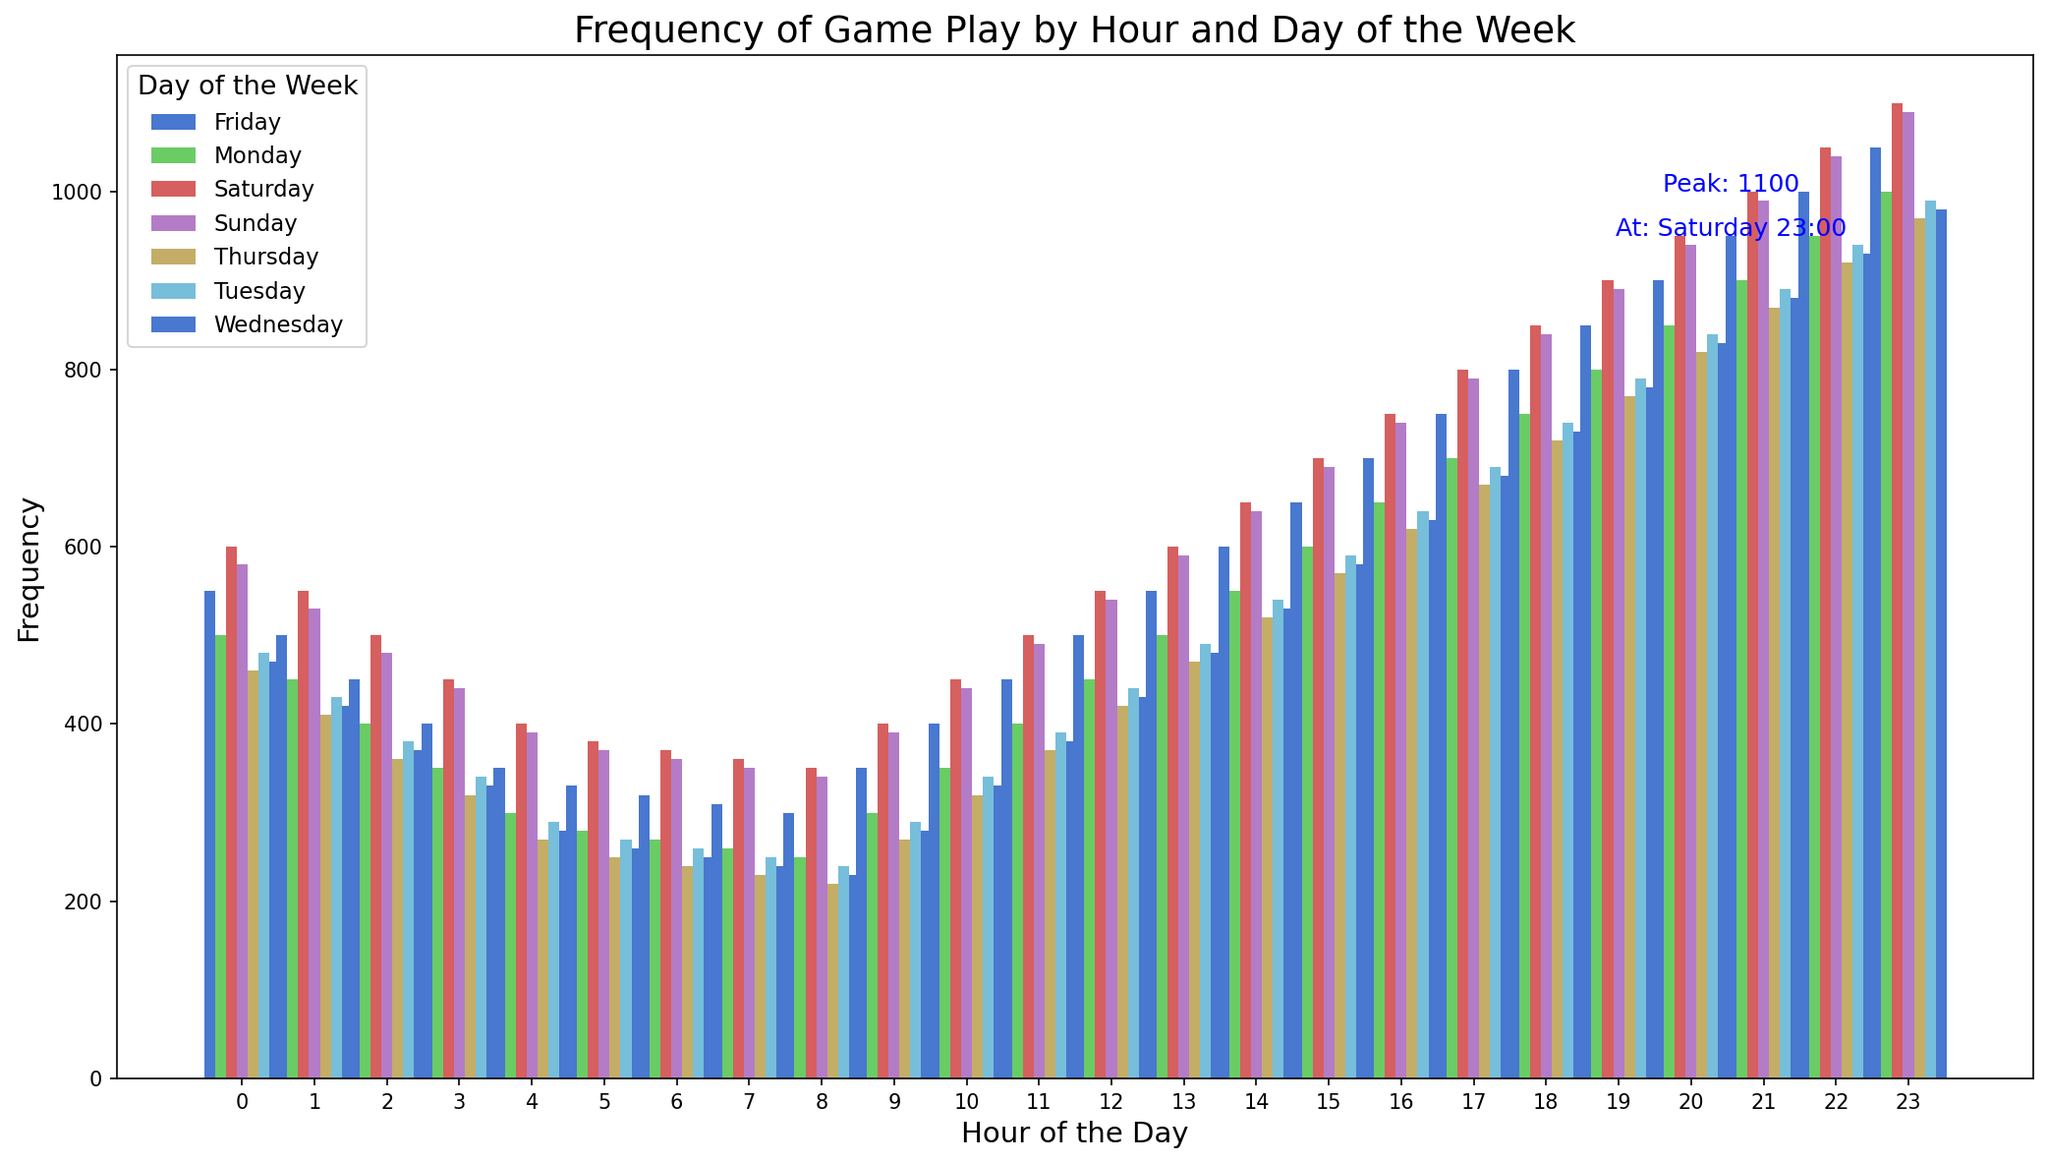What is the peak frequency of game play and when does it occur? The text annotation indicates that the peak frequency is 1100, and it occurs on Saturday at 23:00. This can be seen directly below the second text annotation on the figure.
Answer: 1100 on Saturday at 23:00 Which day of the week shows the highest frequency of game play overall? By visually inspecting the height of the bars, Saturday generally shows higher bars, indicating more frequent game play compared to other days. This is further supported by the peak frequency annotation for Saturday.
Answer: Saturday During which hour(s) of the day does game play see a significant rise? From the bar chart, the bars start increasing significantly around 14:00 to 21:00 on most days, with the highest bars typically seen in the evening hours from 20:00 to 23:00. This suggests a rise during these hours.
Answer: 14:00 to 21:00 What time of the week has the lowest frequency of game play? Observing the shortest bars, the frequency is lowest around 06:00 to 08:00 on all days, as these bars are consistently shorter compared to other time slots.
Answer: Around 06:00 to 08:00 How does the frequency of game play at 18:00 on Friday compare to the frequency at 18:00 on Tuesday? From the bars corresponding to 18:00 on both Friday and Tuesday, the bar for Friday is taller. The frequencies are 800 for Friday and 740 for Tuesday, indicating that game play at 18:00 on Friday is higher.
Answer: 800 on Friday vs 740 on Tuesday What is the average frequency of game play from 20:00 to 23:00 on Mondays? To find the average, sum the frequencies of Monday from 20:00 to 23:00 (850 + 900 + 950 + 1000 = 3700) and divide by 4 (the number of hours). 3700 / 4 = 925
Answer: 925 Which day has the lowest frequency at 04:00, and what is the value? By comparing the heights of the bars at 04:00, Thursday has the shortest bar with a frequency of 270, reflecting the lowest game play at this hour.
Answer: Thursday (270) What trend do you observe in game play frequency on Sundays from 16:00 to 23:00? The bars for Sunday from 16:00 to 23:00 increase in height, indicating a steady rise in frequency. Frequencies are from 740 to 1090.
Answer: Steady increase What is the range of game play frequency on Wednesdays? The minimum frequency on Wednesday is 230 at 08:00 and the maximum frequency is 980 at 23:00. The range is calculated as 980 - 230 = 750.
Answer: 750 Is there a common peak hour for game play across different days? Comparing the top heights of the bars across different days, 23:00 often has one of the tallest bars for most days, indicating it is a common peak hour for game play.
Answer: 23:00 